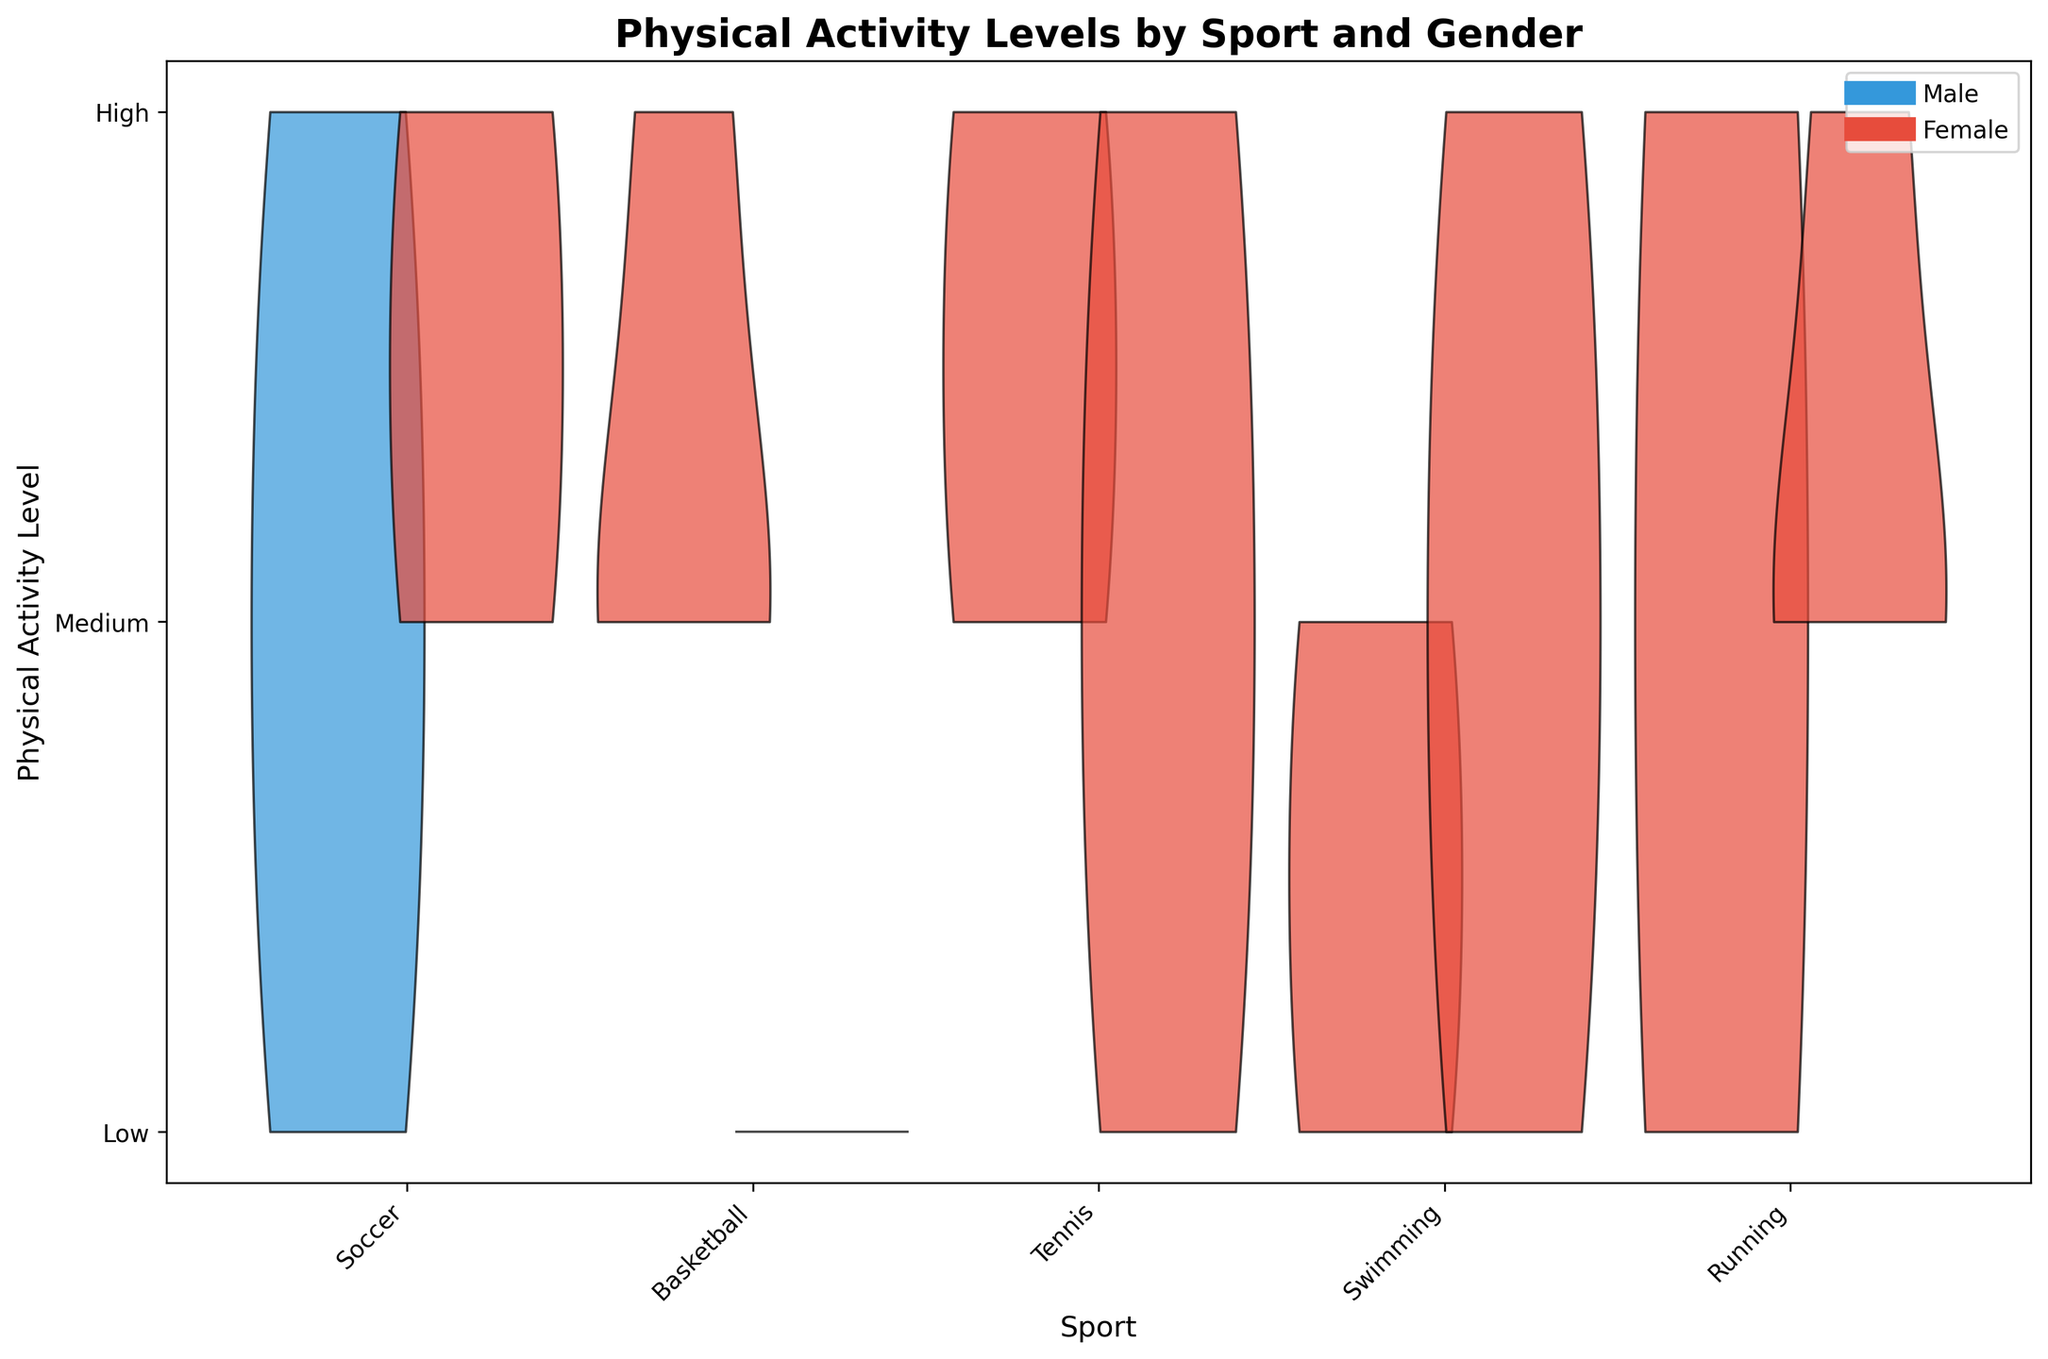What is the title of the chart? The title is usually displayed at the top of the chart. In this case, it provides an overview of what the chart represents. It reads "Physical Activity Levels by Sport and Gender".
Answer: Physical Activity Levels by Sport and Gender How many sports are represented in the chart? By counting the number of different sports labels on the x-axis, we can determine that there are 5 distinct sports shown: Soccer, Basketball, Tennis, Swimming, and Running.
Answer: 5 Which gender has a higher distribution of 'High' physical activity in Soccer? We look at the split violin parts for Soccer. The blue (male) side shows a higher density extending to the 'High' activity level than the red (female) side.
Answer: Male In Swimming, which gender has more low physical activity levels? By examining the violin plot for Swimming, the red (female) side has a higher density at the 'Low' activity level than the blue (male) side.
Answer: Female For the sport of Running, how do the physical activity level distributions compare between genders? By comparing the two halves for Running, both blue (male) and red (female) sides have similar distributions in terms of 'High' and 'Medium' levels, but the male side extends more towards low activity.
Answer: Males have a broader range, particularly towards low activity Which sport shows the most equal distribution between genders for the 'Medium' physical activity level? Observing the center parts of each violin plot for the 'Medium' activity level, Tennis shows a balanced distribution between blue (male) and red (female) sides.
Answer: Tennis Is there any sport where males do not have any 'Low' physical activity levels? Checking each blue half across sports, Soccer is the sport where there is no apparent blue density at the 'Low' activity level.
Answer: Soccer In which sport do females have the highest representation in 'High' physical activity levels? By looking at the red halves of each sport, Swimming shows the highest density in the 'High' activity level for females.
Answer: Swimming For Basketball, which physical activity level is most common across both genders? In the Basketball split violin plot, the highest density for both blue and red sides is at the 'Medium' activity level.
Answer: Medium Summarize the physical activity level for females in Tennis. The Tennis female side shows significant density in both 'High' and 'Medium' levels, with a noticeable drop at the 'Low' level.
Answer: Balanced between High and Medium, less in Low 